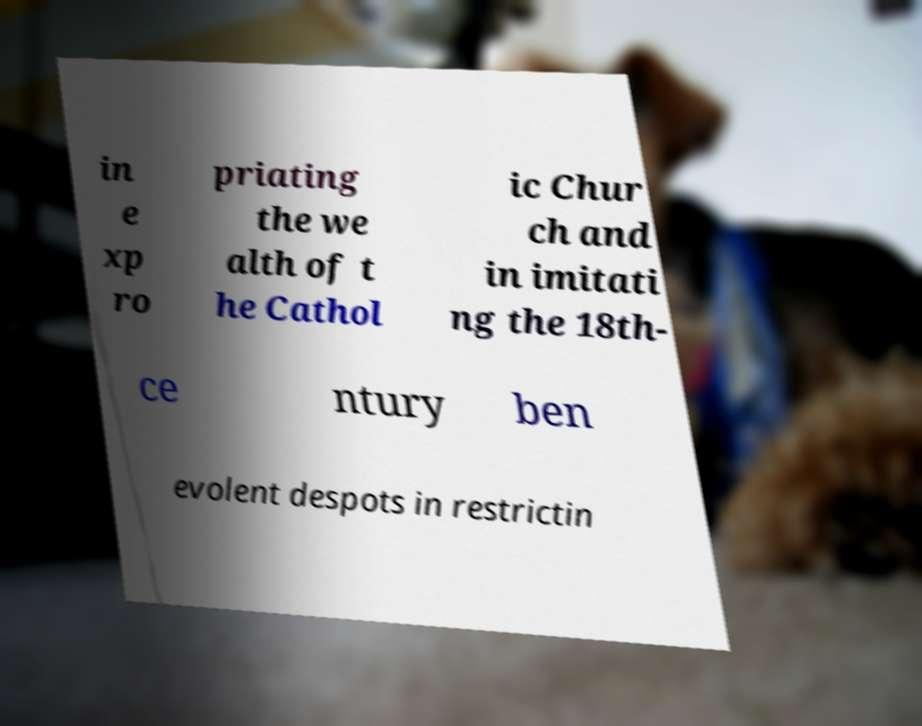I need the written content from this picture converted into text. Can you do that? in e xp ro priating the we alth of t he Cathol ic Chur ch and in imitati ng the 18th- ce ntury ben evolent despots in restrictin 